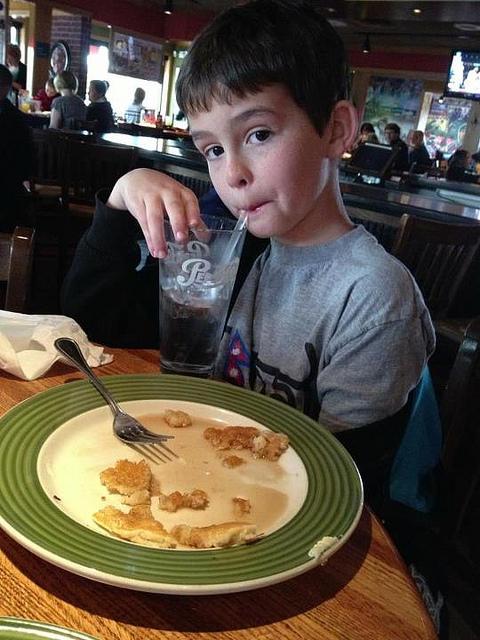Is the boy eating in a restaurant?
Short answer required. Yes. Was there syrup on this boys plate?
Concise answer only. Yes. What is the boy eating?
Quick response, please. Pancakes. What is the boy drinking?
Short answer required. Pepsi. 